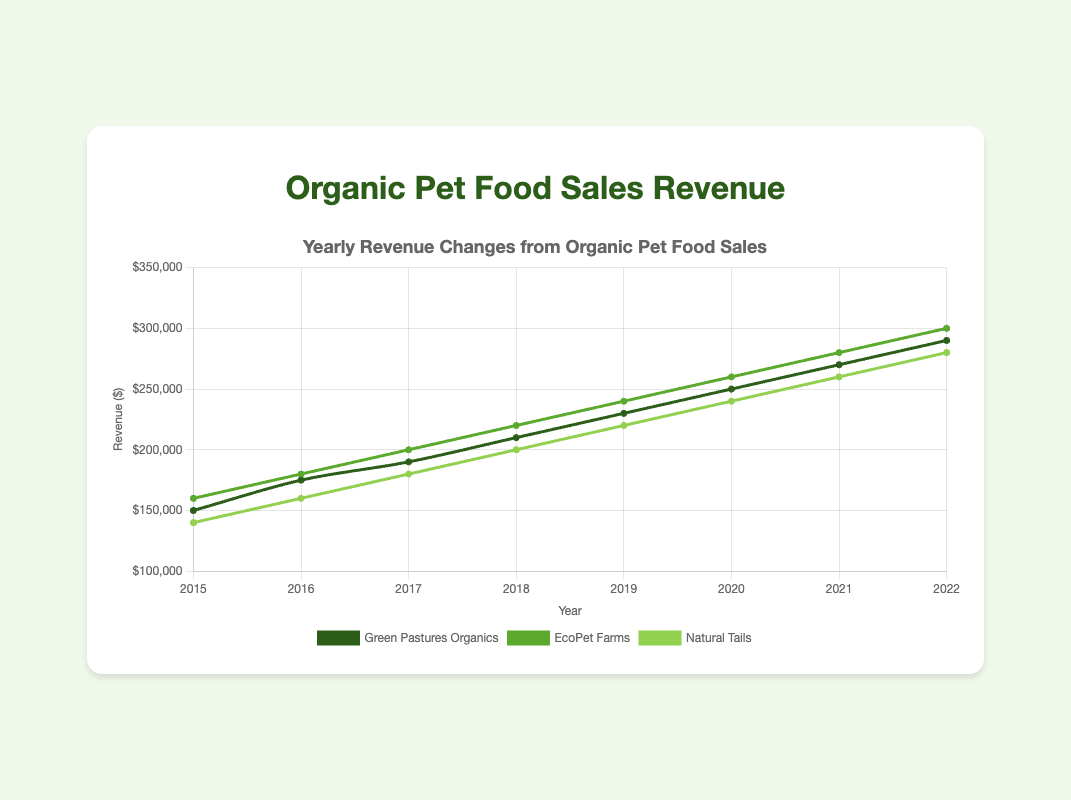What was the revenue for Green Pastures Organics in 2019? Look at the data point for Green Pastures Organics in 2019. The revenue is shown on the y-axis.
Answer: $230,000 Which entity had the highest revenue in 2022? Compare the 2022 revenue values for all three entities: Green Pastures Organics, EcoPet Farms, and Natural Tails. EcoPet Farms has the highest revenue.
Answer: EcoPet Farms What's the total revenue for Natural Tails from 2015 to 2022? Sum the yearly revenue values for Natural Tails from 2015 to 2022: $140,000 + $160,000 + $180,000 + $200,000 + $220,000 + $240,000 + $260,000 + $280,000.
Answer: $1,680,000 Which entity showed the steadiest growth in revenue over the years? Observe the trend lines for each entity. All entities show steady growth, but EcoPet Farms appears slightly more consistent with a linear trend.
Answer: EcoPet Farms What is the average yearly growth in revenue for Green Pastures Organics from 2015 to 2022? Calculate the year-on-year difference and find the average: ((175000-150000) + (190000-175000) + (210000-190000) + (230000-210000) + (250000-230000) + (270000-250000) + (290000-270000)) / 7.
Answer: $20,000 How much higher was EcoPet Farms' revenue in 2022 compared to Green Pastures Organics? Subtract Green Pastures Organics' 2022 revenue from EcoPet Farms' 2022 revenue: $300,000 - $290,000.
Answer: $10,000 Which year did each entity have the lowest revenue and what was the amount? Look at the first data point for each entity (2015): Green Pastures Organics ($150,000), EcoPet Farms ($160,000), and Natural Tails ($140,000).
Answer: 2015: Green Pastures Organics ($150,000), EcoPet Farms ($160,000), Natural Tails ($140,000) From 2015 to 2022, which entity had the largest single-year revenue increase and in which year? Find the largest single-year revenue increase for each entity and compare: EcoPet Farms increased by $20,000 multiple times, the highest single-year increase.
Answer: EcoPet Farms (2016, 2017, 2018, 2019, 2020, 2021, 2022 each year $20,000 increase) What is the difference between the highest and lowest revenue values for Natural Tails during the period? Find the highest and lowest values: highest in 2022 ($280,000) and lowest in 2015 ($140,000). The difference is: $280,000 - $140,000.
Answer: $140,000 